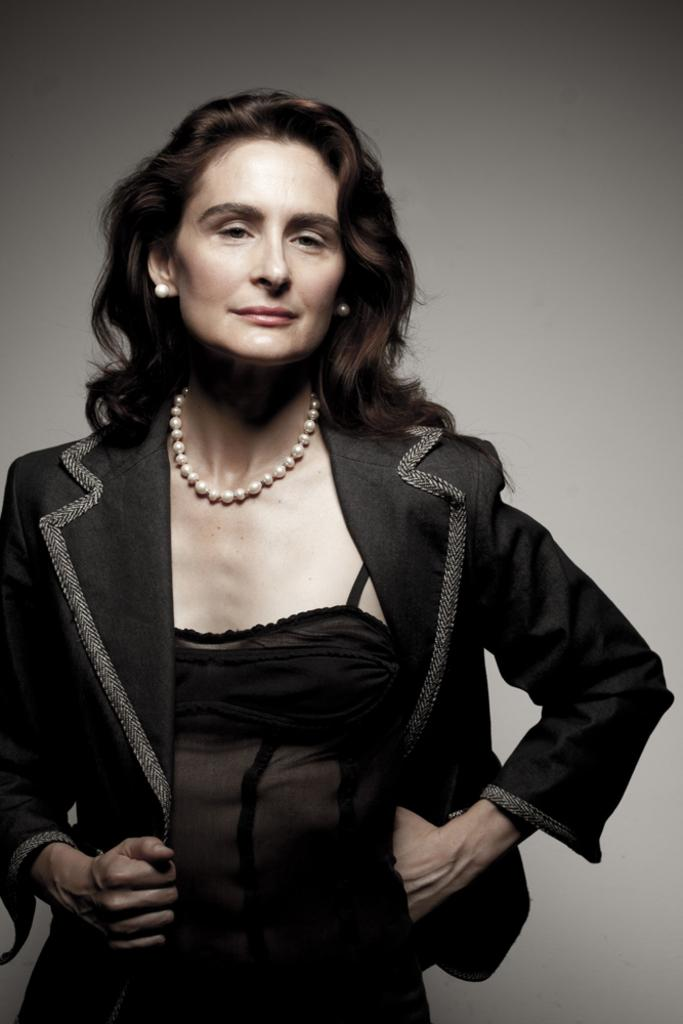What is the main subject of the picture? The main subject of the picture is a woman. What is the woman doing in the picture? The woman is standing in the picture. What is the woman wearing on her upper body? The woman is wearing a black coat and a black dress. What type of jewelry is the woman wearing? The woman is wearing a white pearl chain and studs. What is the background of the picture? There is a white backdrop in the picture. Can you describe the creature that is jumping in the picture? There is no creature present in the image, nor is there any jumping activity depicted. 